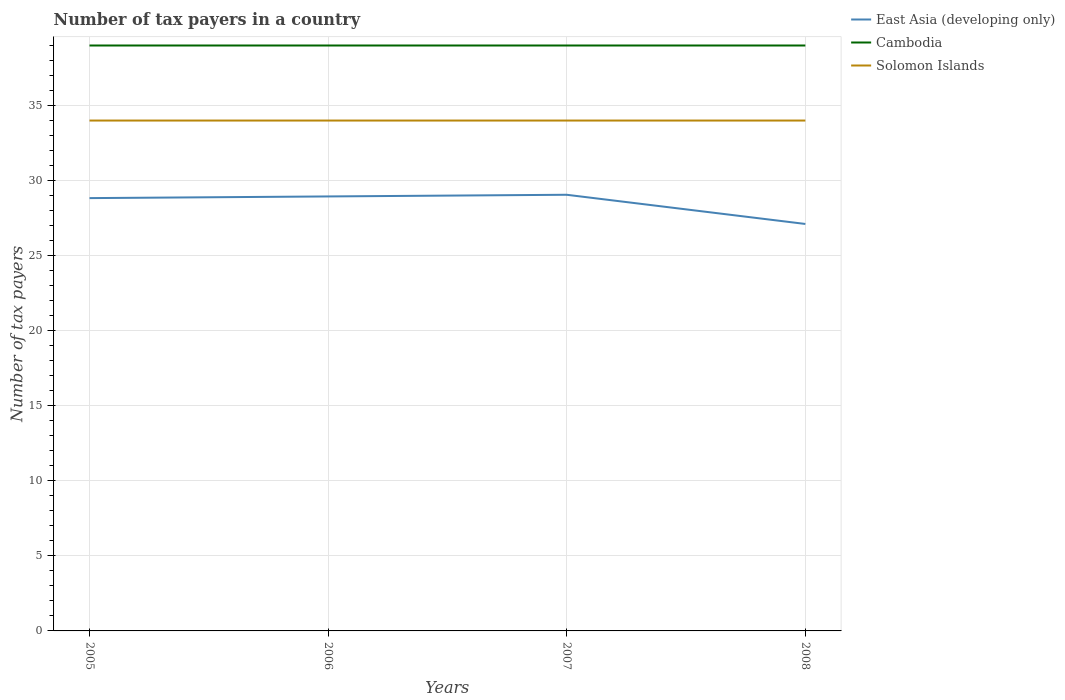How many different coloured lines are there?
Give a very brief answer. 3. Across all years, what is the maximum number of tax payers in in Solomon Islands?
Make the answer very short. 34. What is the total number of tax payers in in East Asia (developing only) in the graph?
Your response must be concise. 1.94. Is the number of tax payers in in Solomon Islands strictly greater than the number of tax payers in in East Asia (developing only) over the years?
Offer a terse response. No. How many lines are there?
Offer a terse response. 3. What is the difference between two consecutive major ticks on the Y-axis?
Give a very brief answer. 5. How many legend labels are there?
Your response must be concise. 3. What is the title of the graph?
Ensure brevity in your answer.  Number of tax payers in a country. Does "Poland" appear as one of the legend labels in the graph?
Offer a terse response. No. What is the label or title of the Y-axis?
Keep it short and to the point. Number of tax payers. What is the Number of tax payers of East Asia (developing only) in 2005?
Your answer should be very brief. 28.83. What is the Number of tax payers in Cambodia in 2005?
Offer a terse response. 39. What is the Number of tax payers of Solomon Islands in 2005?
Give a very brief answer. 34. What is the Number of tax payers of East Asia (developing only) in 2006?
Provide a short and direct response. 28.94. What is the Number of tax payers of Cambodia in 2006?
Give a very brief answer. 39. What is the Number of tax payers of East Asia (developing only) in 2007?
Offer a terse response. 29.06. What is the Number of tax payers in East Asia (developing only) in 2008?
Offer a very short reply. 27.11. What is the Number of tax payers in Cambodia in 2008?
Your answer should be compact. 39. What is the Number of tax payers of Solomon Islands in 2008?
Your response must be concise. 34. Across all years, what is the maximum Number of tax payers of East Asia (developing only)?
Provide a succinct answer. 29.06. Across all years, what is the maximum Number of tax payers of Solomon Islands?
Ensure brevity in your answer.  34. Across all years, what is the minimum Number of tax payers in East Asia (developing only)?
Keep it short and to the point. 27.11. Across all years, what is the minimum Number of tax payers of Solomon Islands?
Provide a short and direct response. 34. What is the total Number of tax payers in East Asia (developing only) in the graph?
Ensure brevity in your answer.  113.94. What is the total Number of tax payers of Cambodia in the graph?
Offer a terse response. 156. What is the total Number of tax payers of Solomon Islands in the graph?
Give a very brief answer. 136. What is the difference between the Number of tax payers of East Asia (developing only) in 2005 and that in 2006?
Ensure brevity in your answer.  -0.11. What is the difference between the Number of tax payers of Cambodia in 2005 and that in 2006?
Your answer should be very brief. 0. What is the difference between the Number of tax payers of Solomon Islands in 2005 and that in 2006?
Ensure brevity in your answer.  0. What is the difference between the Number of tax payers in East Asia (developing only) in 2005 and that in 2007?
Keep it short and to the point. -0.22. What is the difference between the Number of tax payers of Cambodia in 2005 and that in 2007?
Provide a short and direct response. 0. What is the difference between the Number of tax payers in Solomon Islands in 2005 and that in 2007?
Offer a very short reply. 0. What is the difference between the Number of tax payers in East Asia (developing only) in 2005 and that in 2008?
Offer a very short reply. 1.72. What is the difference between the Number of tax payers in East Asia (developing only) in 2006 and that in 2007?
Provide a short and direct response. -0.11. What is the difference between the Number of tax payers in Cambodia in 2006 and that in 2007?
Provide a succinct answer. 0. What is the difference between the Number of tax payers in Solomon Islands in 2006 and that in 2007?
Offer a terse response. 0. What is the difference between the Number of tax payers of East Asia (developing only) in 2006 and that in 2008?
Your answer should be compact. 1.83. What is the difference between the Number of tax payers in East Asia (developing only) in 2007 and that in 2008?
Ensure brevity in your answer.  1.94. What is the difference between the Number of tax payers of East Asia (developing only) in 2005 and the Number of tax payers of Cambodia in 2006?
Ensure brevity in your answer.  -10.17. What is the difference between the Number of tax payers in East Asia (developing only) in 2005 and the Number of tax payers in Solomon Islands in 2006?
Give a very brief answer. -5.17. What is the difference between the Number of tax payers in Cambodia in 2005 and the Number of tax payers in Solomon Islands in 2006?
Your answer should be compact. 5. What is the difference between the Number of tax payers of East Asia (developing only) in 2005 and the Number of tax payers of Cambodia in 2007?
Provide a succinct answer. -10.17. What is the difference between the Number of tax payers of East Asia (developing only) in 2005 and the Number of tax payers of Solomon Islands in 2007?
Provide a succinct answer. -5.17. What is the difference between the Number of tax payers in Cambodia in 2005 and the Number of tax payers in Solomon Islands in 2007?
Offer a very short reply. 5. What is the difference between the Number of tax payers of East Asia (developing only) in 2005 and the Number of tax payers of Cambodia in 2008?
Keep it short and to the point. -10.17. What is the difference between the Number of tax payers in East Asia (developing only) in 2005 and the Number of tax payers in Solomon Islands in 2008?
Provide a short and direct response. -5.17. What is the difference between the Number of tax payers of Cambodia in 2005 and the Number of tax payers of Solomon Islands in 2008?
Offer a terse response. 5. What is the difference between the Number of tax payers of East Asia (developing only) in 2006 and the Number of tax payers of Cambodia in 2007?
Ensure brevity in your answer.  -10.06. What is the difference between the Number of tax payers of East Asia (developing only) in 2006 and the Number of tax payers of Solomon Islands in 2007?
Ensure brevity in your answer.  -5.06. What is the difference between the Number of tax payers of East Asia (developing only) in 2006 and the Number of tax payers of Cambodia in 2008?
Your response must be concise. -10.06. What is the difference between the Number of tax payers in East Asia (developing only) in 2006 and the Number of tax payers in Solomon Islands in 2008?
Give a very brief answer. -5.06. What is the difference between the Number of tax payers of East Asia (developing only) in 2007 and the Number of tax payers of Cambodia in 2008?
Provide a short and direct response. -9.94. What is the difference between the Number of tax payers in East Asia (developing only) in 2007 and the Number of tax payers in Solomon Islands in 2008?
Make the answer very short. -4.94. What is the average Number of tax payers in East Asia (developing only) per year?
Your answer should be very brief. 28.49. What is the average Number of tax payers in Solomon Islands per year?
Offer a terse response. 34. In the year 2005, what is the difference between the Number of tax payers of East Asia (developing only) and Number of tax payers of Cambodia?
Your answer should be very brief. -10.17. In the year 2005, what is the difference between the Number of tax payers of East Asia (developing only) and Number of tax payers of Solomon Islands?
Provide a short and direct response. -5.17. In the year 2006, what is the difference between the Number of tax payers of East Asia (developing only) and Number of tax payers of Cambodia?
Give a very brief answer. -10.06. In the year 2006, what is the difference between the Number of tax payers in East Asia (developing only) and Number of tax payers in Solomon Islands?
Your answer should be compact. -5.06. In the year 2006, what is the difference between the Number of tax payers of Cambodia and Number of tax payers of Solomon Islands?
Provide a succinct answer. 5. In the year 2007, what is the difference between the Number of tax payers in East Asia (developing only) and Number of tax payers in Cambodia?
Your answer should be very brief. -9.94. In the year 2007, what is the difference between the Number of tax payers in East Asia (developing only) and Number of tax payers in Solomon Islands?
Make the answer very short. -4.94. In the year 2008, what is the difference between the Number of tax payers in East Asia (developing only) and Number of tax payers in Cambodia?
Your answer should be compact. -11.89. In the year 2008, what is the difference between the Number of tax payers in East Asia (developing only) and Number of tax payers in Solomon Islands?
Offer a very short reply. -6.89. What is the ratio of the Number of tax payers of East Asia (developing only) in 2005 to that in 2006?
Your answer should be very brief. 1. What is the ratio of the Number of tax payers of Solomon Islands in 2005 to that in 2006?
Give a very brief answer. 1. What is the ratio of the Number of tax payers of East Asia (developing only) in 2005 to that in 2007?
Give a very brief answer. 0.99. What is the ratio of the Number of tax payers of Cambodia in 2005 to that in 2007?
Ensure brevity in your answer.  1. What is the ratio of the Number of tax payers in Solomon Islands in 2005 to that in 2007?
Keep it short and to the point. 1. What is the ratio of the Number of tax payers in East Asia (developing only) in 2005 to that in 2008?
Offer a terse response. 1.06. What is the ratio of the Number of tax payers in Cambodia in 2005 to that in 2008?
Provide a short and direct response. 1. What is the ratio of the Number of tax payers in Solomon Islands in 2005 to that in 2008?
Make the answer very short. 1. What is the ratio of the Number of tax payers in East Asia (developing only) in 2006 to that in 2007?
Offer a very short reply. 1. What is the ratio of the Number of tax payers of Solomon Islands in 2006 to that in 2007?
Your response must be concise. 1. What is the ratio of the Number of tax payers of East Asia (developing only) in 2006 to that in 2008?
Your response must be concise. 1.07. What is the ratio of the Number of tax payers of Solomon Islands in 2006 to that in 2008?
Provide a succinct answer. 1. What is the ratio of the Number of tax payers of East Asia (developing only) in 2007 to that in 2008?
Your answer should be compact. 1.07. What is the ratio of the Number of tax payers of Cambodia in 2007 to that in 2008?
Provide a succinct answer. 1. What is the ratio of the Number of tax payers in Solomon Islands in 2007 to that in 2008?
Offer a very short reply. 1. What is the difference between the highest and the second highest Number of tax payers in East Asia (developing only)?
Provide a succinct answer. 0.11. What is the difference between the highest and the lowest Number of tax payers of East Asia (developing only)?
Ensure brevity in your answer.  1.94. What is the difference between the highest and the lowest Number of tax payers of Cambodia?
Give a very brief answer. 0. What is the difference between the highest and the lowest Number of tax payers in Solomon Islands?
Ensure brevity in your answer.  0. 